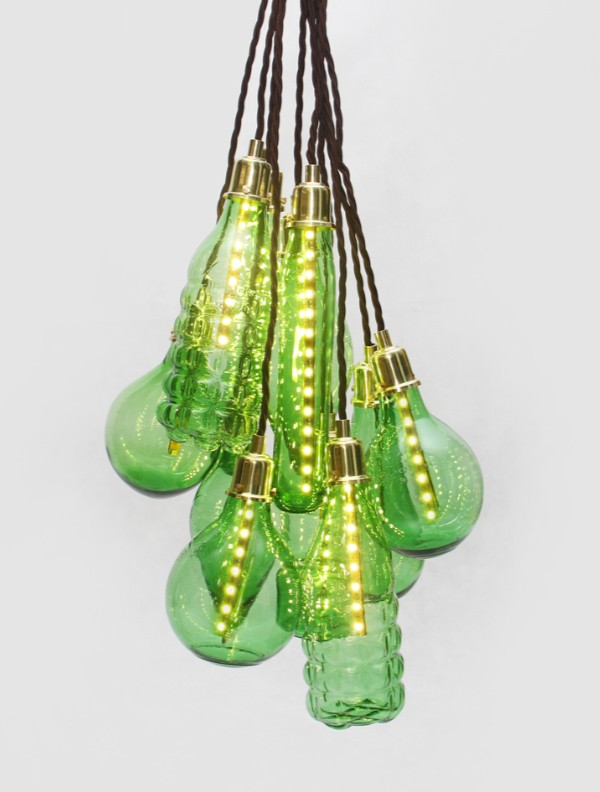These light fixtures have such an interesting design. What elements might influence their placement and arrangement in a living space? The placement and arrangement of these light fixtures in a living space can be influenced by several elements, such as the room's layout, existing decor, and the functional need for illumination. Placing these fixtures together creates a focal point, perfect for over a dining table or in the center of a living room. Spacing them differently can add layers and dimensions to the setting, highlighting art pieces or specific areas. Considering the fixtures' vibrant green hue, they would contrast beautifully against neutral backgrounds, while their organic shapes would complement natural elements like wooden furniture or indoor plants. Additionally, adjusting the height of each fixture adds depth and visual interest, emphasizing the bespoke quality of the design. Would these lights be suitable for a modern office space, and how might they impact the environment there? Yes, these light fixtures could be an excellent addition to a modern office space. Their unique design challenges the conventional, often sterile look of office lighting, adding character and a touch of creativity to the environment. The green glass and organic shapes introduce a calming, nature-inspired element that can enhance the office ambiance, potentially boosting productivity and creativity. The warm light from the LEDs fosters a welcoming and relaxed atmosphere, making the workspace more comfortable and visually appealing. Using these fixtures in meeting rooms or collaborative spaces can encourage a more relaxed and engaging setting, conducive to brainstorming and team collaboration. 